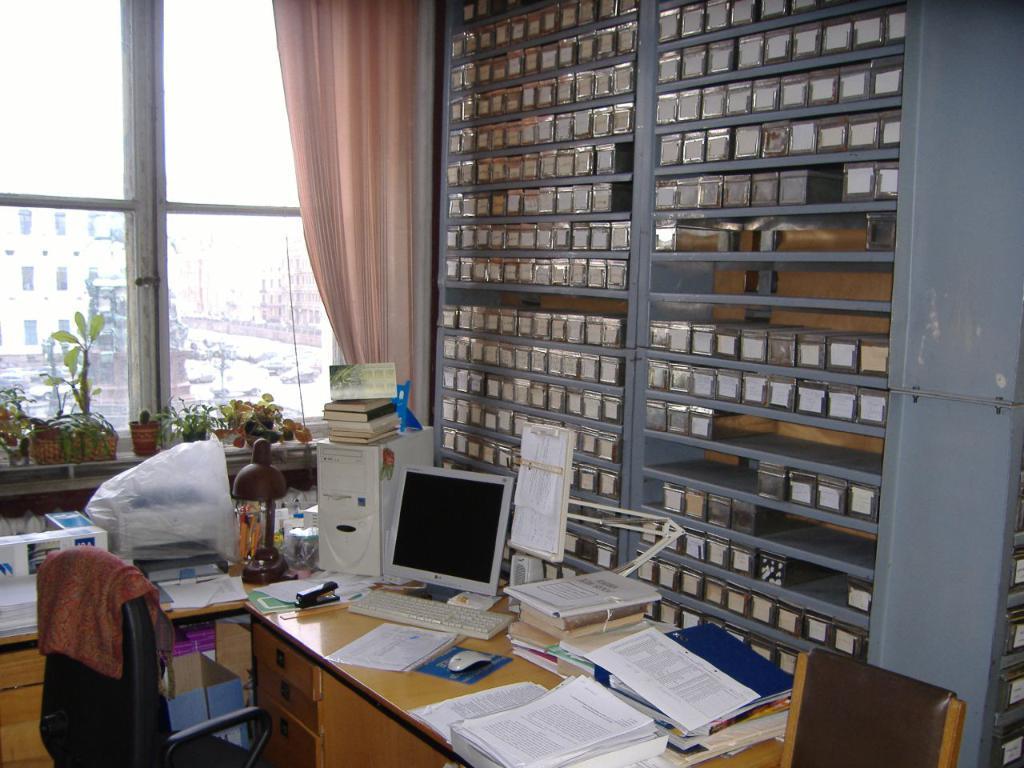Could you give a brief overview of what you see in this image? In this picture on the table there is a monitor, key board, in front of the keyboard there is a paper, mouse pad with a mouse, and to the right corner of the table there are pages, files and books. And to the left side there is a window with pink curtain and some pots with plants on it. And to the right side there is a cupboard with many boxes in it. 